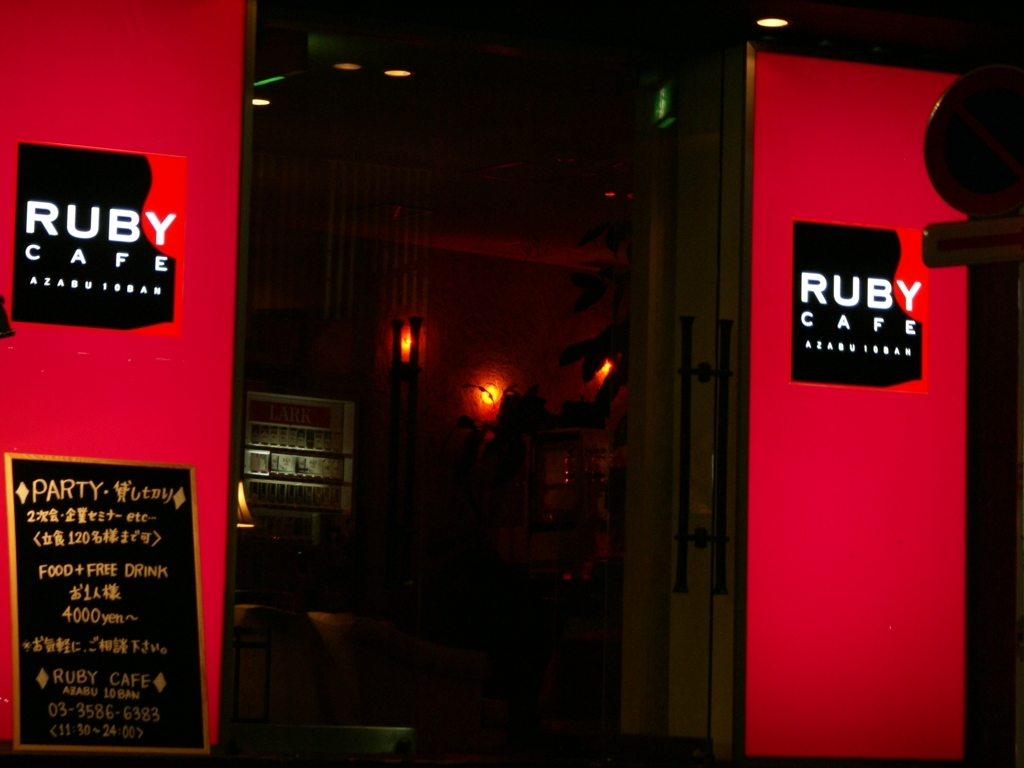Can you tell what time of day it might be based on the lighting in the image? Considering the darkness surrounding the illuminated signs and the absence of natural light, it suggests that the photo was taken at night. This is the time when such signs are most effective in drawing attention and guiding potential customers to their destination. 